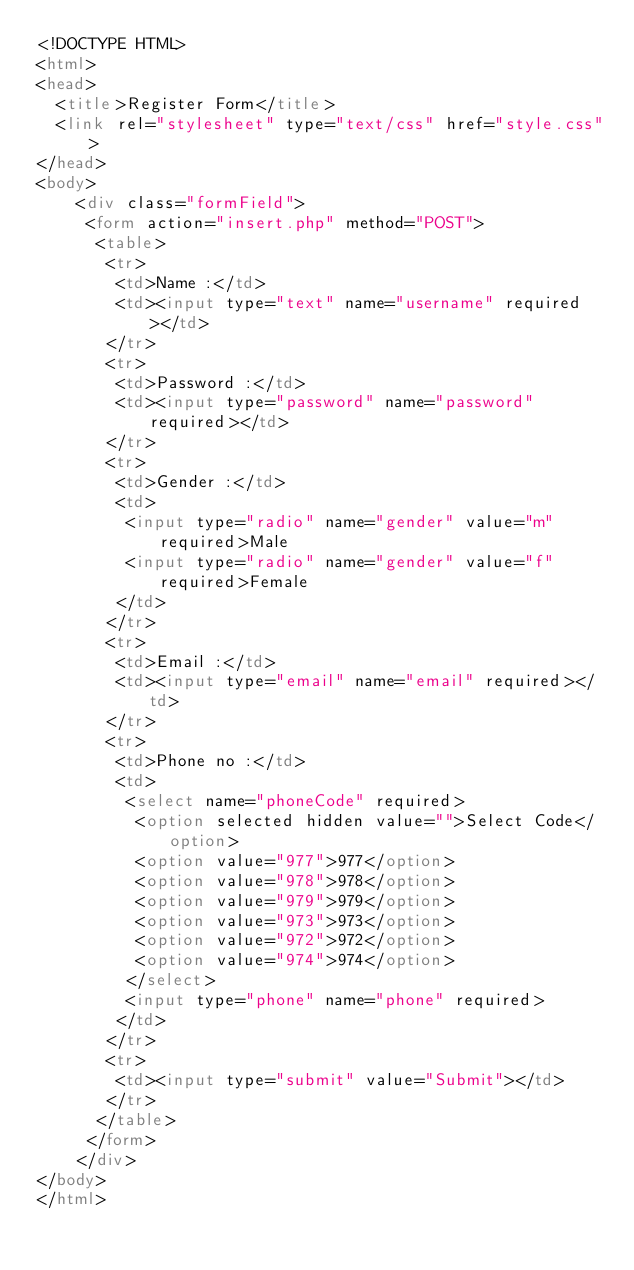Convert code to text. <code><loc_0><loc_0><loc_500><loc_500><_HTML_><!DOCTYPE HTML>
<html>
<head>
  <title>Register Form</title>
  <link rel="stylesheet" type="text/css" href="style.css">
</head>
<body>
	<div class="formField">
	 <form action="insert.php" method="POST">
	  <table>
	   <tr>
		<td>Name :</td>
		<td><input type="text" name="username" required></td>
	   </tr>
	   <tr>
		<td>Password :</td>
		<td><input type="password" name="password" required></td>
	   </tr>
	   <tr>
		<td>Gender :</td>
		<td>
		 <input type="radio" name="gender" value="m" required>Male
		 <input type="radio" name="gender" value="f" required>Female
		</td>
	   </tr>
	   <tr>
		<td>Email :</td>
		<td><input type="email" name="email" required></td>
	   </tr> 
	   <tr>
		<td>Phone no :</td>
		<td>
		 <select name="phoneCode" required>
		  <option selected hidden value="">Select Code</option>
		  <option value="977">977</option>
		  <option value="978">978</option>
		  <option value="979">979</option>
		  <option value="973">973</option>
		  <option value="972">972</option>
		  <option value="974">974</option>
		 </select>
		 <input type="phone" name="phone" required>
		</td>
	   </tr>
	   <tr>
		<td><input type="submit" value="Submit"></td>
	   </tr>
	  </table>
	 </form>
	</div>
</body>
</html></code> 